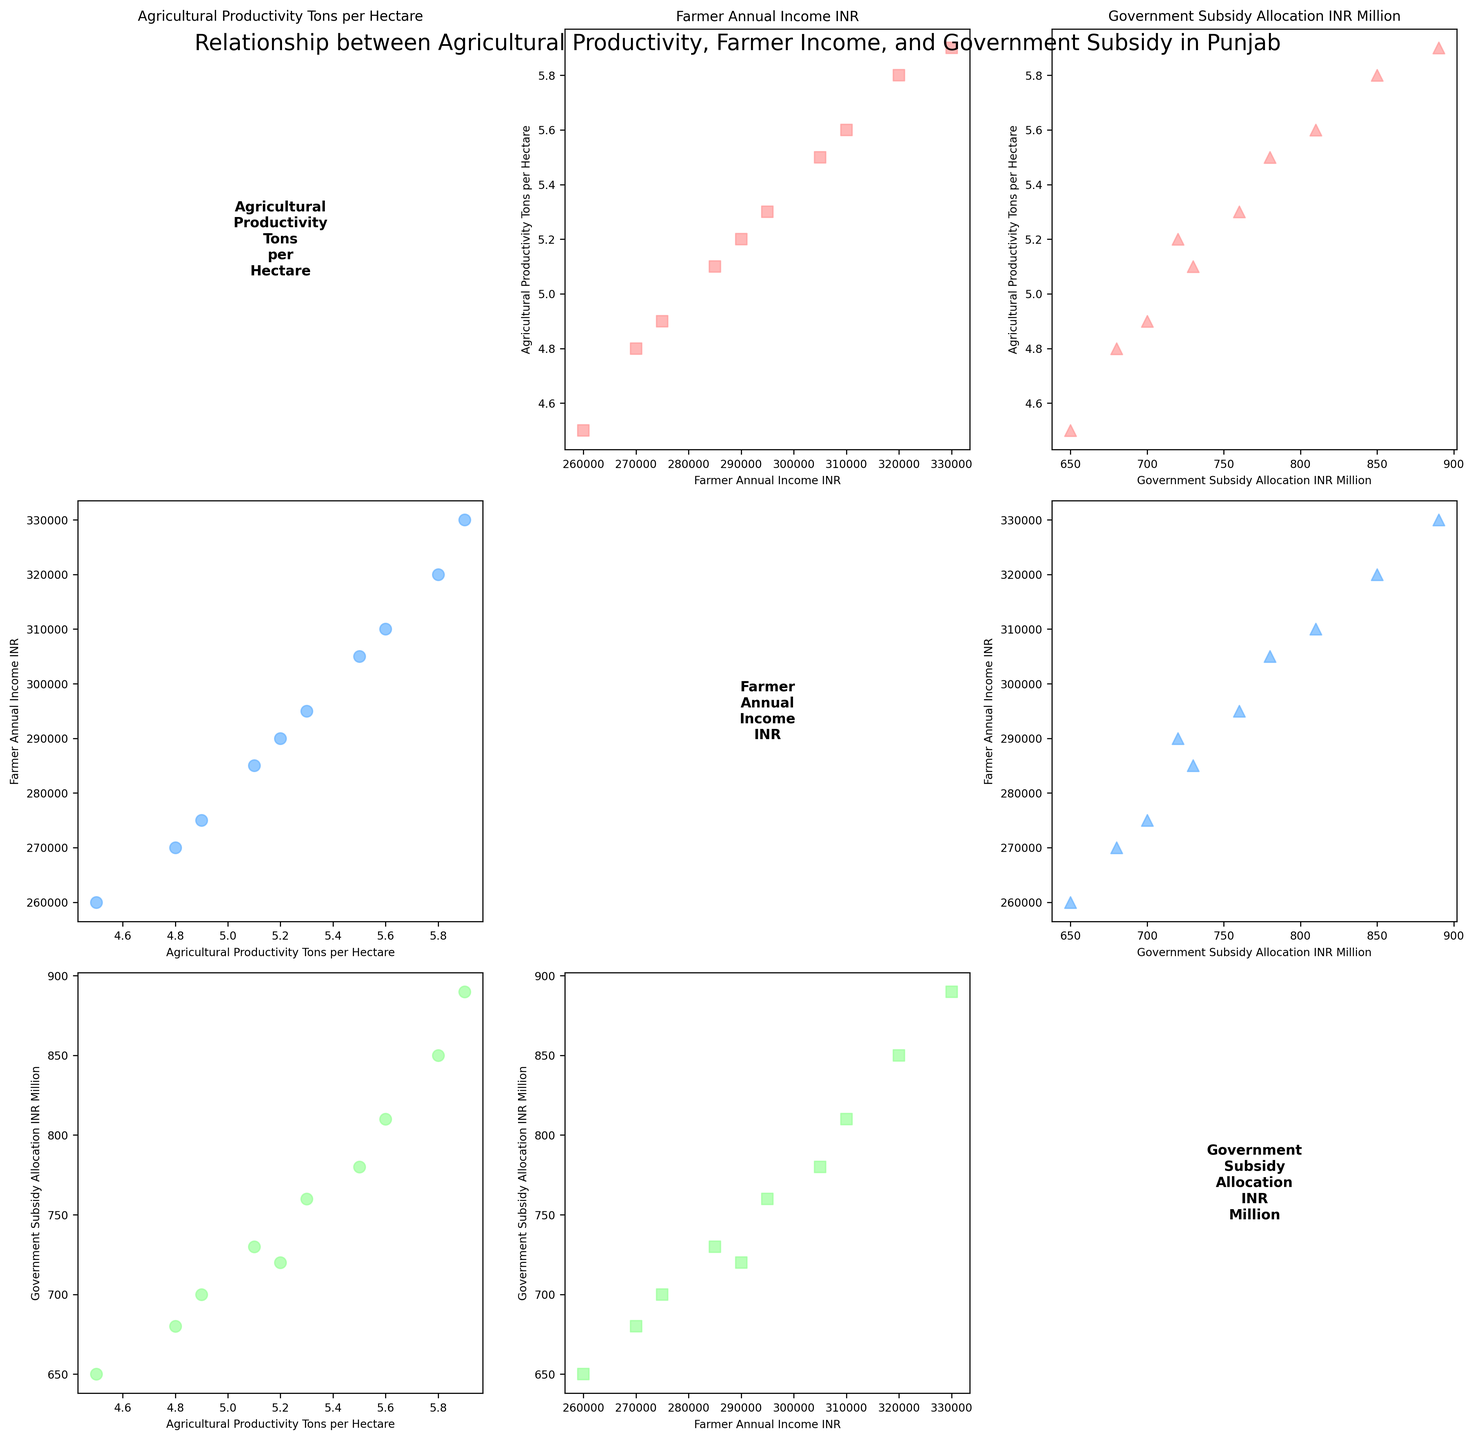What does the title of the plot indicate? The title of the plot “Relationship between Agricultural Productivity, Farmer Income, and Government Subsidy in Punjab” indicates that the scatterplot matrix is analyzing how these three variables interact with each other across different regions in Punjab.
Answer: Relationship between Agricultural Productivity, Farmer Income, and Government Subsidy in Punjab How many data points are there for each variable? Each variable - Agricultural Productivity, Farmer Annual Income, and Government Subsidy Allocation - has 10 data points corresponding to the 10 regions in Punjab.
Answer: 10 What color is used to represent the relationship between Agricultural Productivity and Government Subsidy Allocation? The color used to represent the relationship between Agricultural Productivity and Government Subsidy Allocation is light red.
Answer: Light red Between which two variables is there the highest scatter spread? By visually inspecting the scatter plots in the matrix, the highest scatter spread seems to be between Agricultural Productivity per hectare and Farmer Annual Income since the points are more widely dispersed compared to other pairs.
Answer: Agricultural Productivity and Farmer Annual Income Which region has the highest Agricultural Productivity? From the scatterplot titled "Agricultural Productivity vs Government Subsidy Allocation," the region with the highest Agricultural Productivity is Patiala.
Answer: Patiala Is there a positive correlation between Farmer Annual Income and Government Subsidy Allocation? By looking at the scatterplot comparing Farmer Annual Income and Government Subsidy Allocation, there seems to be a positive correlation as the data points tend to rise together along the plot.
Answer: Yes Which variables are displayed in the scatterplot located at the first row and second column of the figure? The first row and second column scatterplot shows the relationship between Government Subsidy Allocation (x-axis) and Agricultural Productivity (y-axis).
Answer: Government Subsidy Allocation and Agricultural Productivity What can be inferred about the relationship between Agricultural Productivity and Farmer Annual Income by comparing the scatterplots in their respective positions on the matrix? By comparing the scatterplots of Agricultural Productivity vs Farmer Annual Income (and vice versa), it appears that regions with higher agricultural productivity tend to have higher farmer incomes, suggesting a possible positive correlation.
Answer: Positive correlation What is the x-axis label of the middle scatterplot in the second row? The x-axis label of the middle scatterplot in the second row is "Farmer Annual Income."
Answer: Farmer Annual Income If you were to rank the regions based on Government Subsidy Allocation, which region would be in the middle? Observing from the scatterplot with Government Subsidy Allocation on the y-axis, Jalandhar would be in the middle with moderate government subsidy allocation amongst the regions.
Answer: Jalandhar 